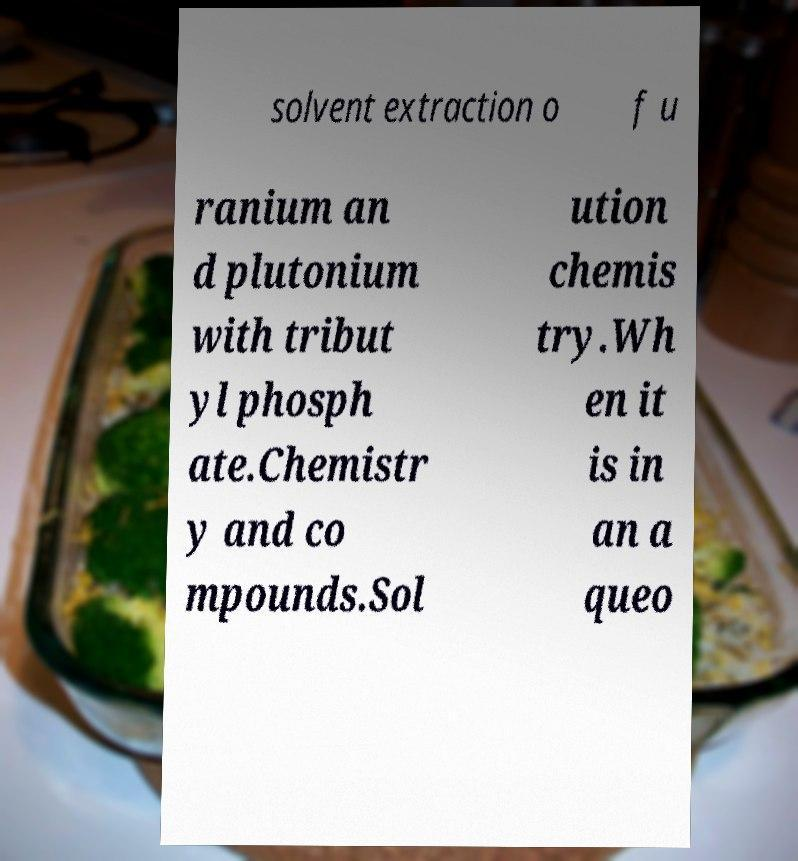Can you accurately transcribe the text from the provided image for me? solvent extraction o f u ranium an d plutonium with tribut yl phosph ate.Chemistr y and co mpounds.Sol ution chemis try.Wh en it is in an a queo 